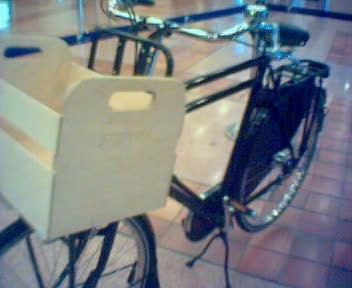What kind of activities might one use this bicycle for? Given its design with a front cargo basket, this bicycle is ideal for urban commuting and running errands. It can be used for grocery shopping, carrying personal items, or delivering goods. It's also suitable for leisurely rides around town or in parks. 